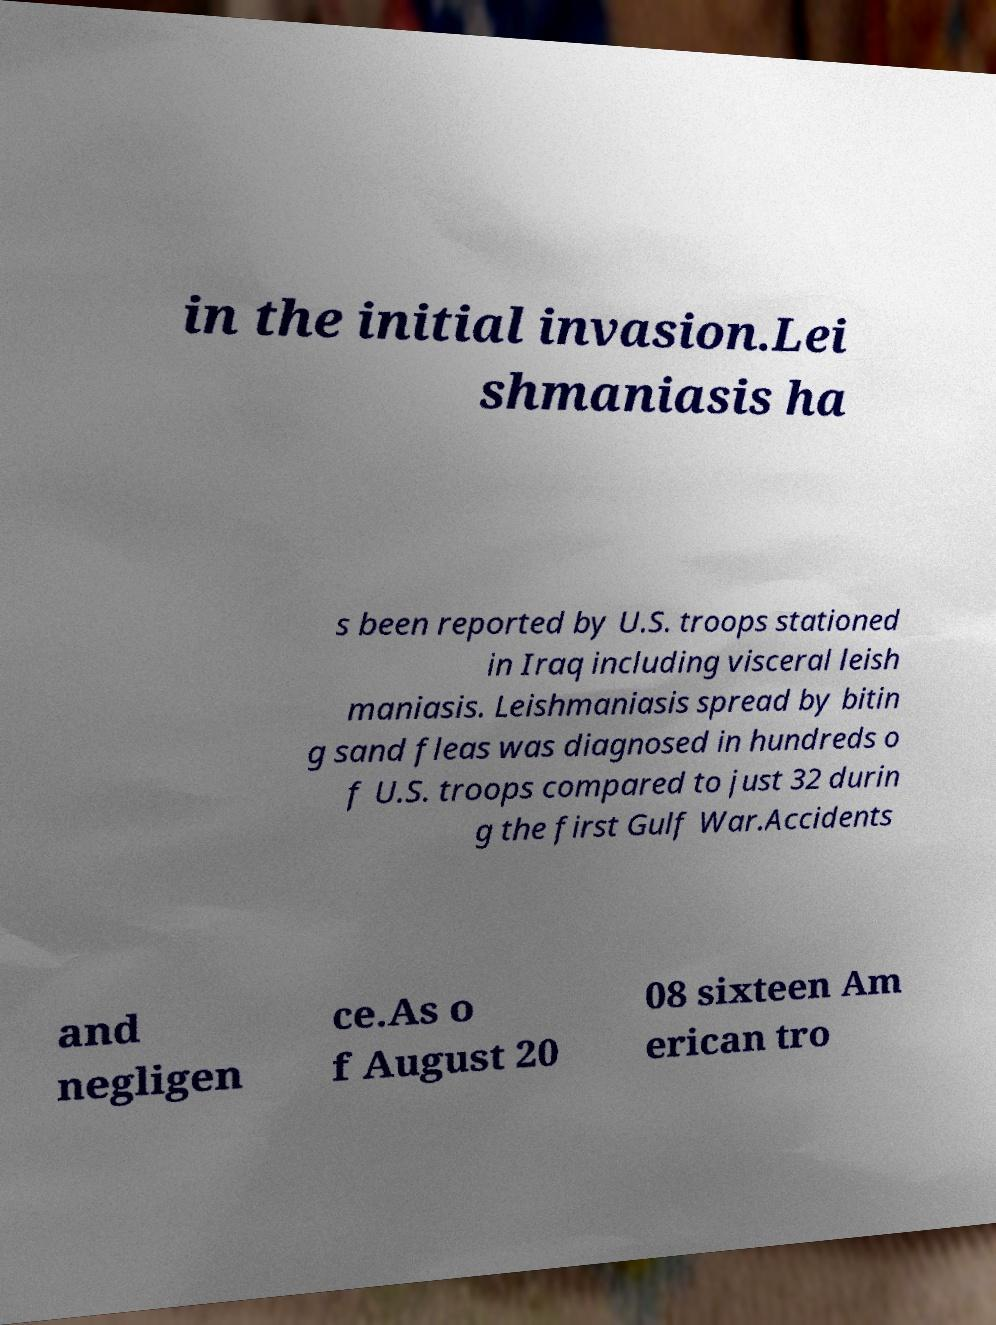Can you accurately transcribe the text from the provided image for me? in the initial invasion.Lei shmaniasis ha s been reported by U.S. troops stationed in Iraq including visceral leish maniasis. Leishmaniasis spread by bitin g sand fleas was diagnosed in hundreds o f U.S. troops compared to just 32 durin g the first Gulf War.Accidents and negligen ce.As o f August 20 08 sixteen Am erican tro 